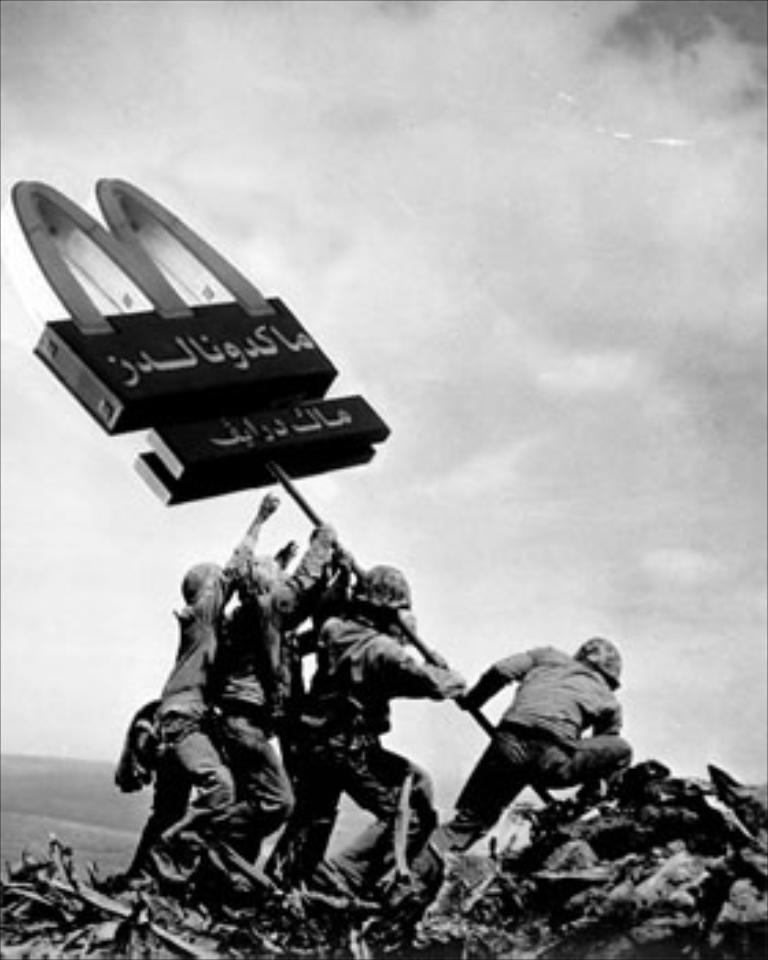How many people are present in the image? There are four persons in the image. What are the four persons doing in the image? The four persons are lifting a board. What type of tray is being used by the persons in the image? There is no tray present in the image; the four persons are lifting a board. Can you confirm the existence of a fifth person in the image? No, there is no mention of a fifth person in the image; there are only four persons present. 